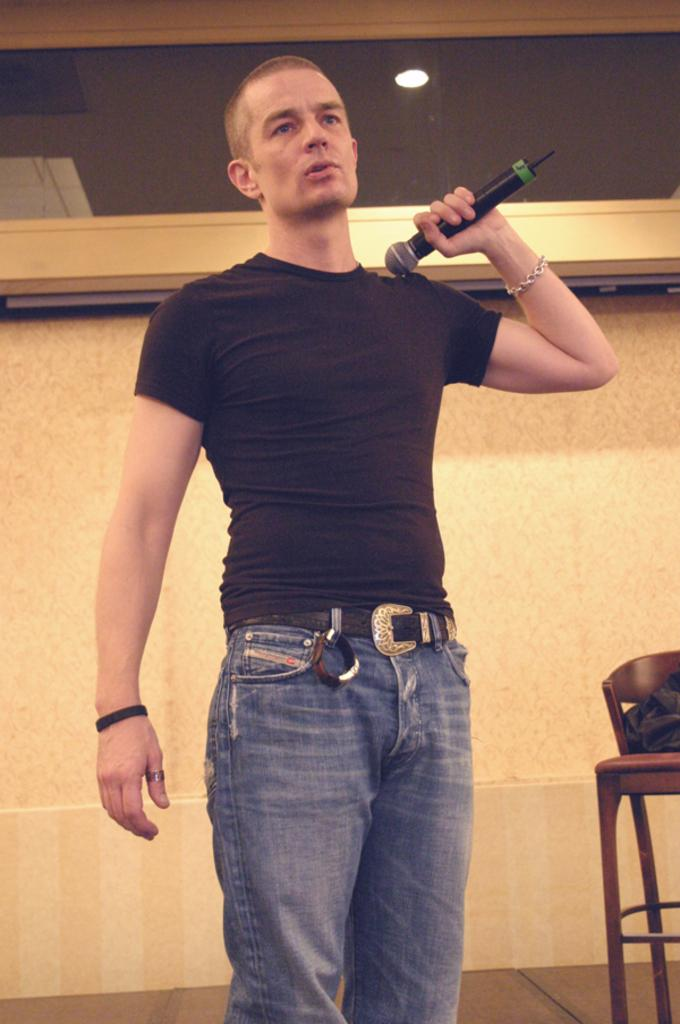What is the man in the image holding? The man is holding a microphone. What can be seen in the background of the image? There is a wall in the background of the image. How would you describe the lighting in the image? The image appears to be well-lit. What type of board is the farmer using in the image? There is no farmer or board present in the image. 